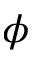<formula> <loc_0><loc_0><loc_500><loc_500>\phi</formula> 